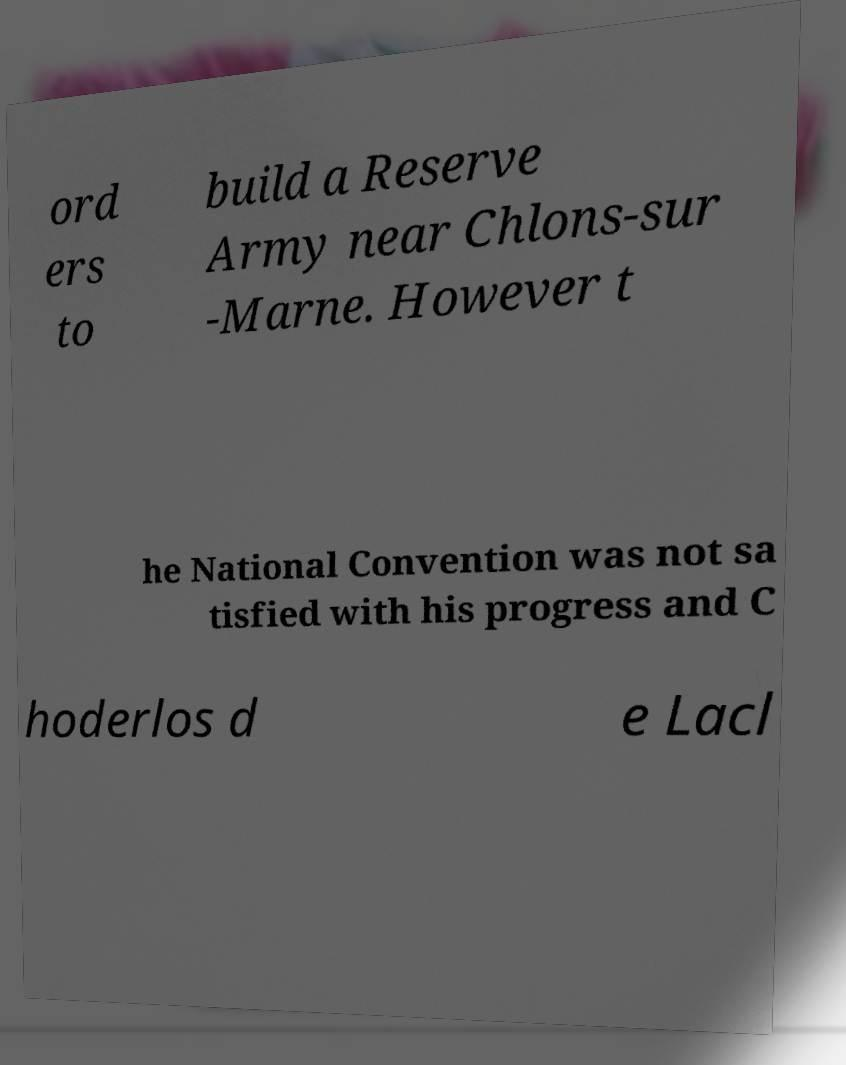There's text embedded in this image that I need extracted. Can you transcribe it verbatim? ord ers to build a Reserve Army near Chlons-sur -Marne. However t he National Convention was not sa tisfied with his progress and C hoderlos d e Lacl 